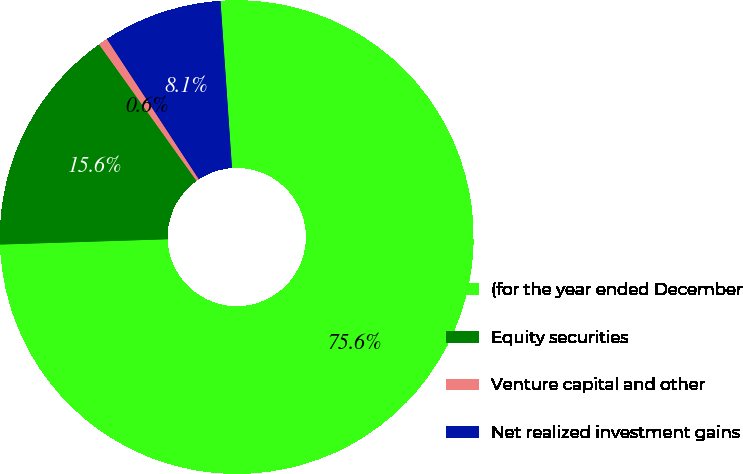Convert chart. <chart><loc_0><loc_0><loc_500><loc_500><pie_chart><fcel>(for the year ended December<fcel>Equity securities<fcel>Venture capital and other<fcel>Net realized investment gains<nl><fcel>75.59%<fcel>15.63%<fcel>0.64%<fcel>8.14%<nl></chart> 